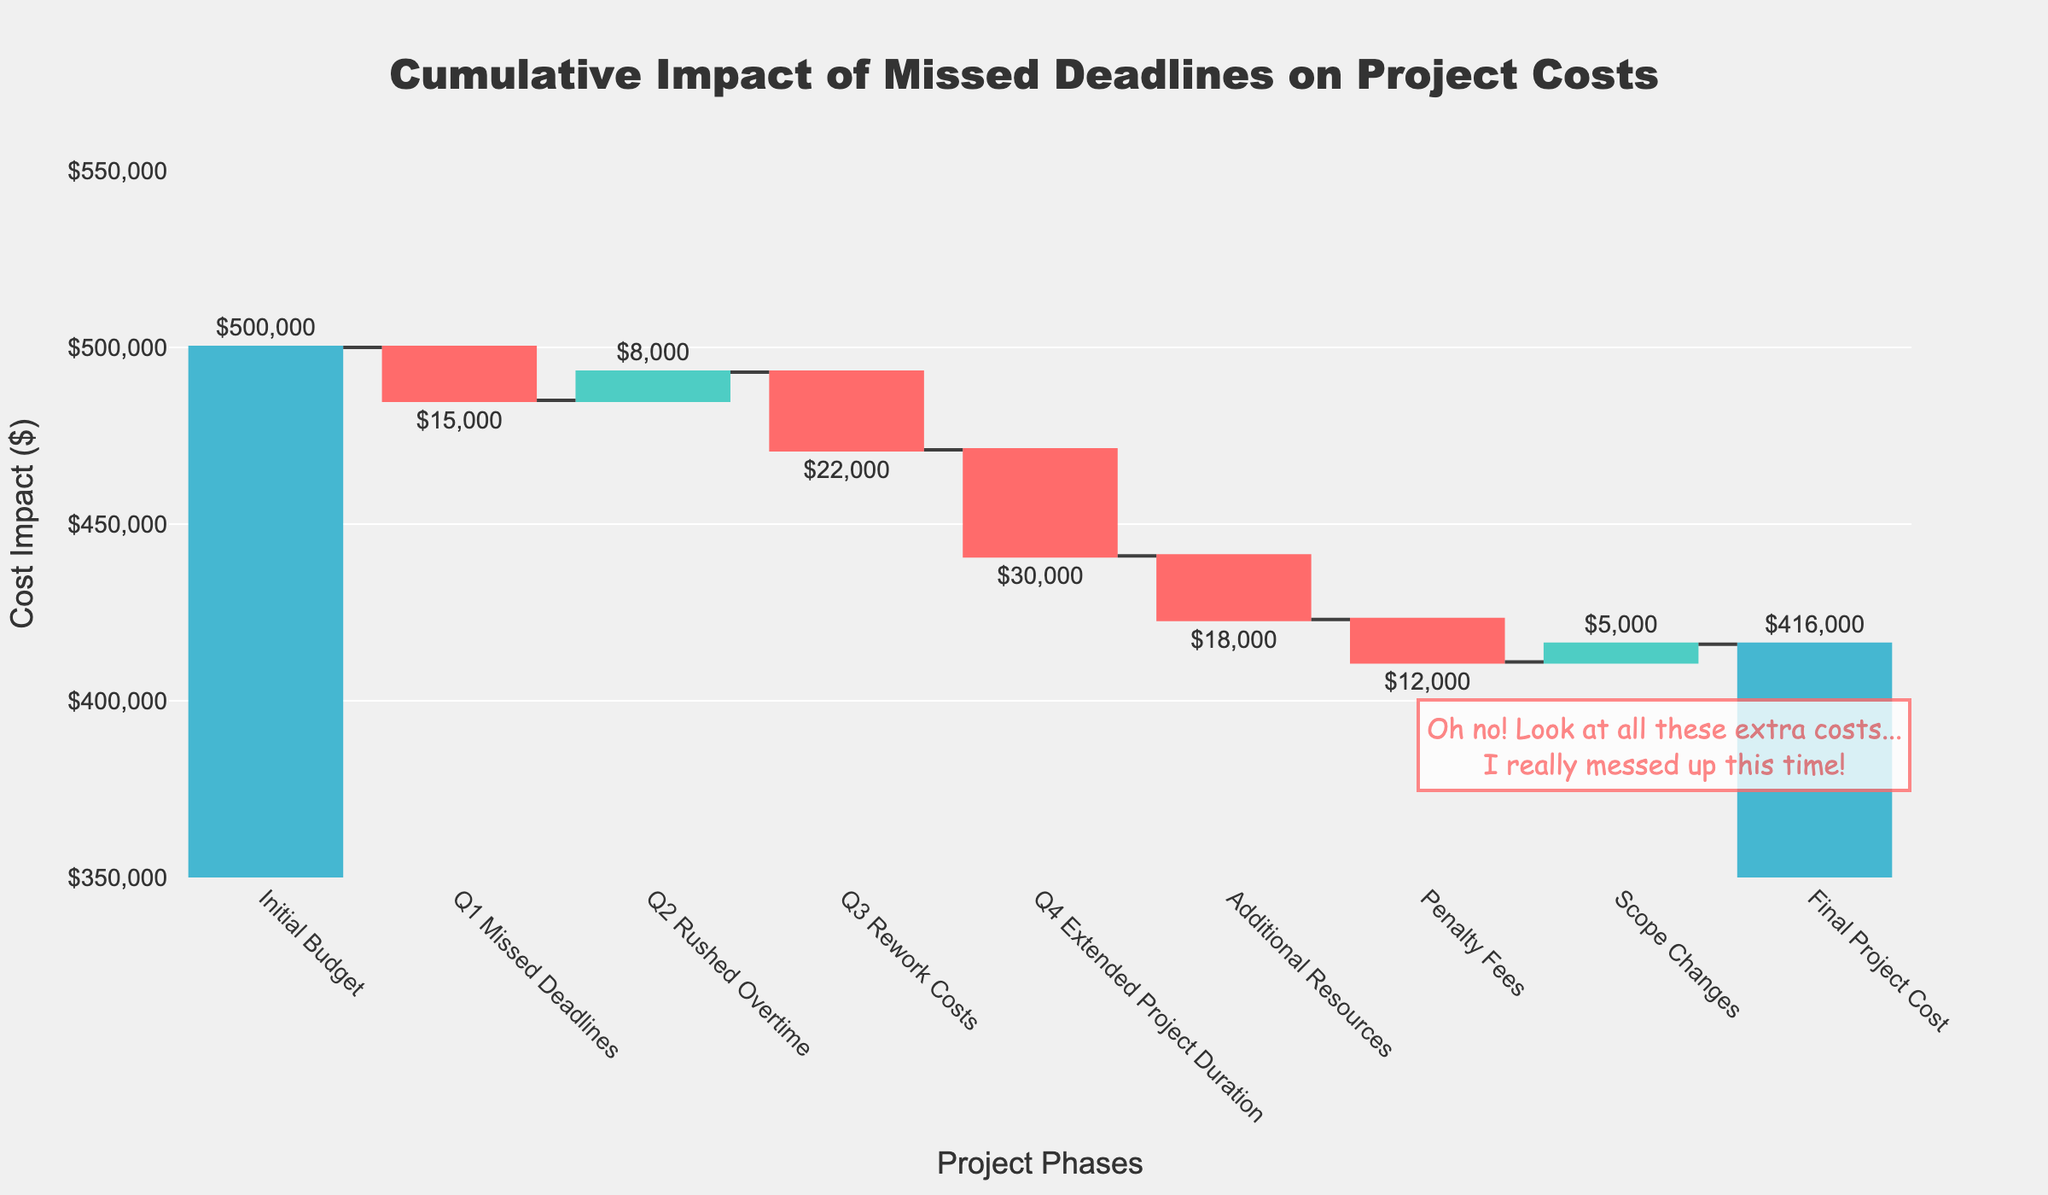How many categories are displayed on the x-axis? The x-axis lists all project phases, counting all unique tick marks or labels will give us the total number. There are 9 project phases from "Initial Budget" to "Final Project Cost".
Answer: 9 What is the total impact of positive changes on the project cost? Identify and sum up all positive values visible in the plot: Q2 Rushed Overtime ($8,000) and Scope Changes ($5,000). Thus, $8,000 + $5,000 = $13,000.
Answer: $13,000 Which project phase has the largest negative impact on the cost? Compare all drop values. The largest deduction is from Q4 Extended Project Duration which reduces the cost by $30,000.
Answer: Q4 Extended Project Duration How much more expensive is the Final Project Cost compared to the Initial Budget? Calculate the difference: Initial Budget ($500,000) - Final Project Cost ($416,000). This equals $500,000 - $416,000 = $84,000.
Answer: $84,000 What is the total cost after Q3 Rework Costs? Sum the Initial Budget ($500,000) and the cumulative impact of the first three categories: Q1 Missed Deadlines (-$15,000), Q2 Rushed Overtime ($8,000), and Q3 Rework Costs (-$22,000). 500,000 - 15,000 + 8,000 - 22,000 = $471,000.
Answer: $471,000 Which phase contributes the smallest decrease in the project cost? Identify the smallest negative value among the decreases: Q1 Missed Deadlines (-$15,000), Q3 Rework Costs (-$22,000), Q4 Extended Project Duration (-$30,000), Additional Resources (-$18,000), Penalty Fees (-$12,000). The Penalty Fees is the smallest with $12,000.
Answer: Penalty Fees If there had been no penalty fees, what would have been the Final Project Cost? Add the Penalty Fees ($12,000) back to the Final Project Cost ($416,000). 416,000 + 12,000 = $428,000.
Answer: $428,000 What phase causes the highest increase in project costs after a decrease? Identify all the increases following a decrease: Q2 Rushed Overtime ($8,000) follows Q1 Missed Deadlines (-$15,000). So, $8,000 is the only scenario that qualifies.
Answer: Q2 Rushed Overtime Between Q1 Missed Deadlines and Q3 Rework Costs, which has a more significant negative impact on the project cost? Compare their values: Q1 Missed Deadlines costs $15,000 whereas Q3 Rework Costs costs $22,000. Thus, Q3 Rework Costs has a bigger negative impact.
Answer: Q3 Rework Costs What can we infer about the project's performance based on the annotations in the graph? Analyze the annotation on the graph: The annotation text indicates a regretful tone implying there were multiple incurred extra costs reflecting the project's cost overruns and mismanagement.
Answer: The project faced significant cost overruns due to mismanagement 